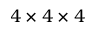<formula> <loc_0><loc_0><loc_500><loc_500>4 \times 4 \times 4</formula> 